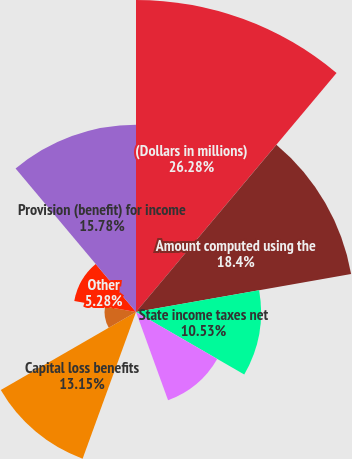<chart> <loc_0><loc_0><loc_500><loc_500><pie_chart><fcel>(Dollars in millions)<fcel>Amount computed using the<fcel>State income taxes net<fcel>Domestic manufacturing<fcel>ESOP dividend payout<fcel>Capital loss benefits<fcel>Change in reserves for tax<fcel>Other<fcel>Provision (benefit) for income<nl><fcel>26.28%<fcel>18.4%<fcel>10.53%<fcel>7.9%<fcel>0.03%<fcel>13.15%<fcel>2.65%<fcel>5.28%<fcel>15.78%<nl></chart> 